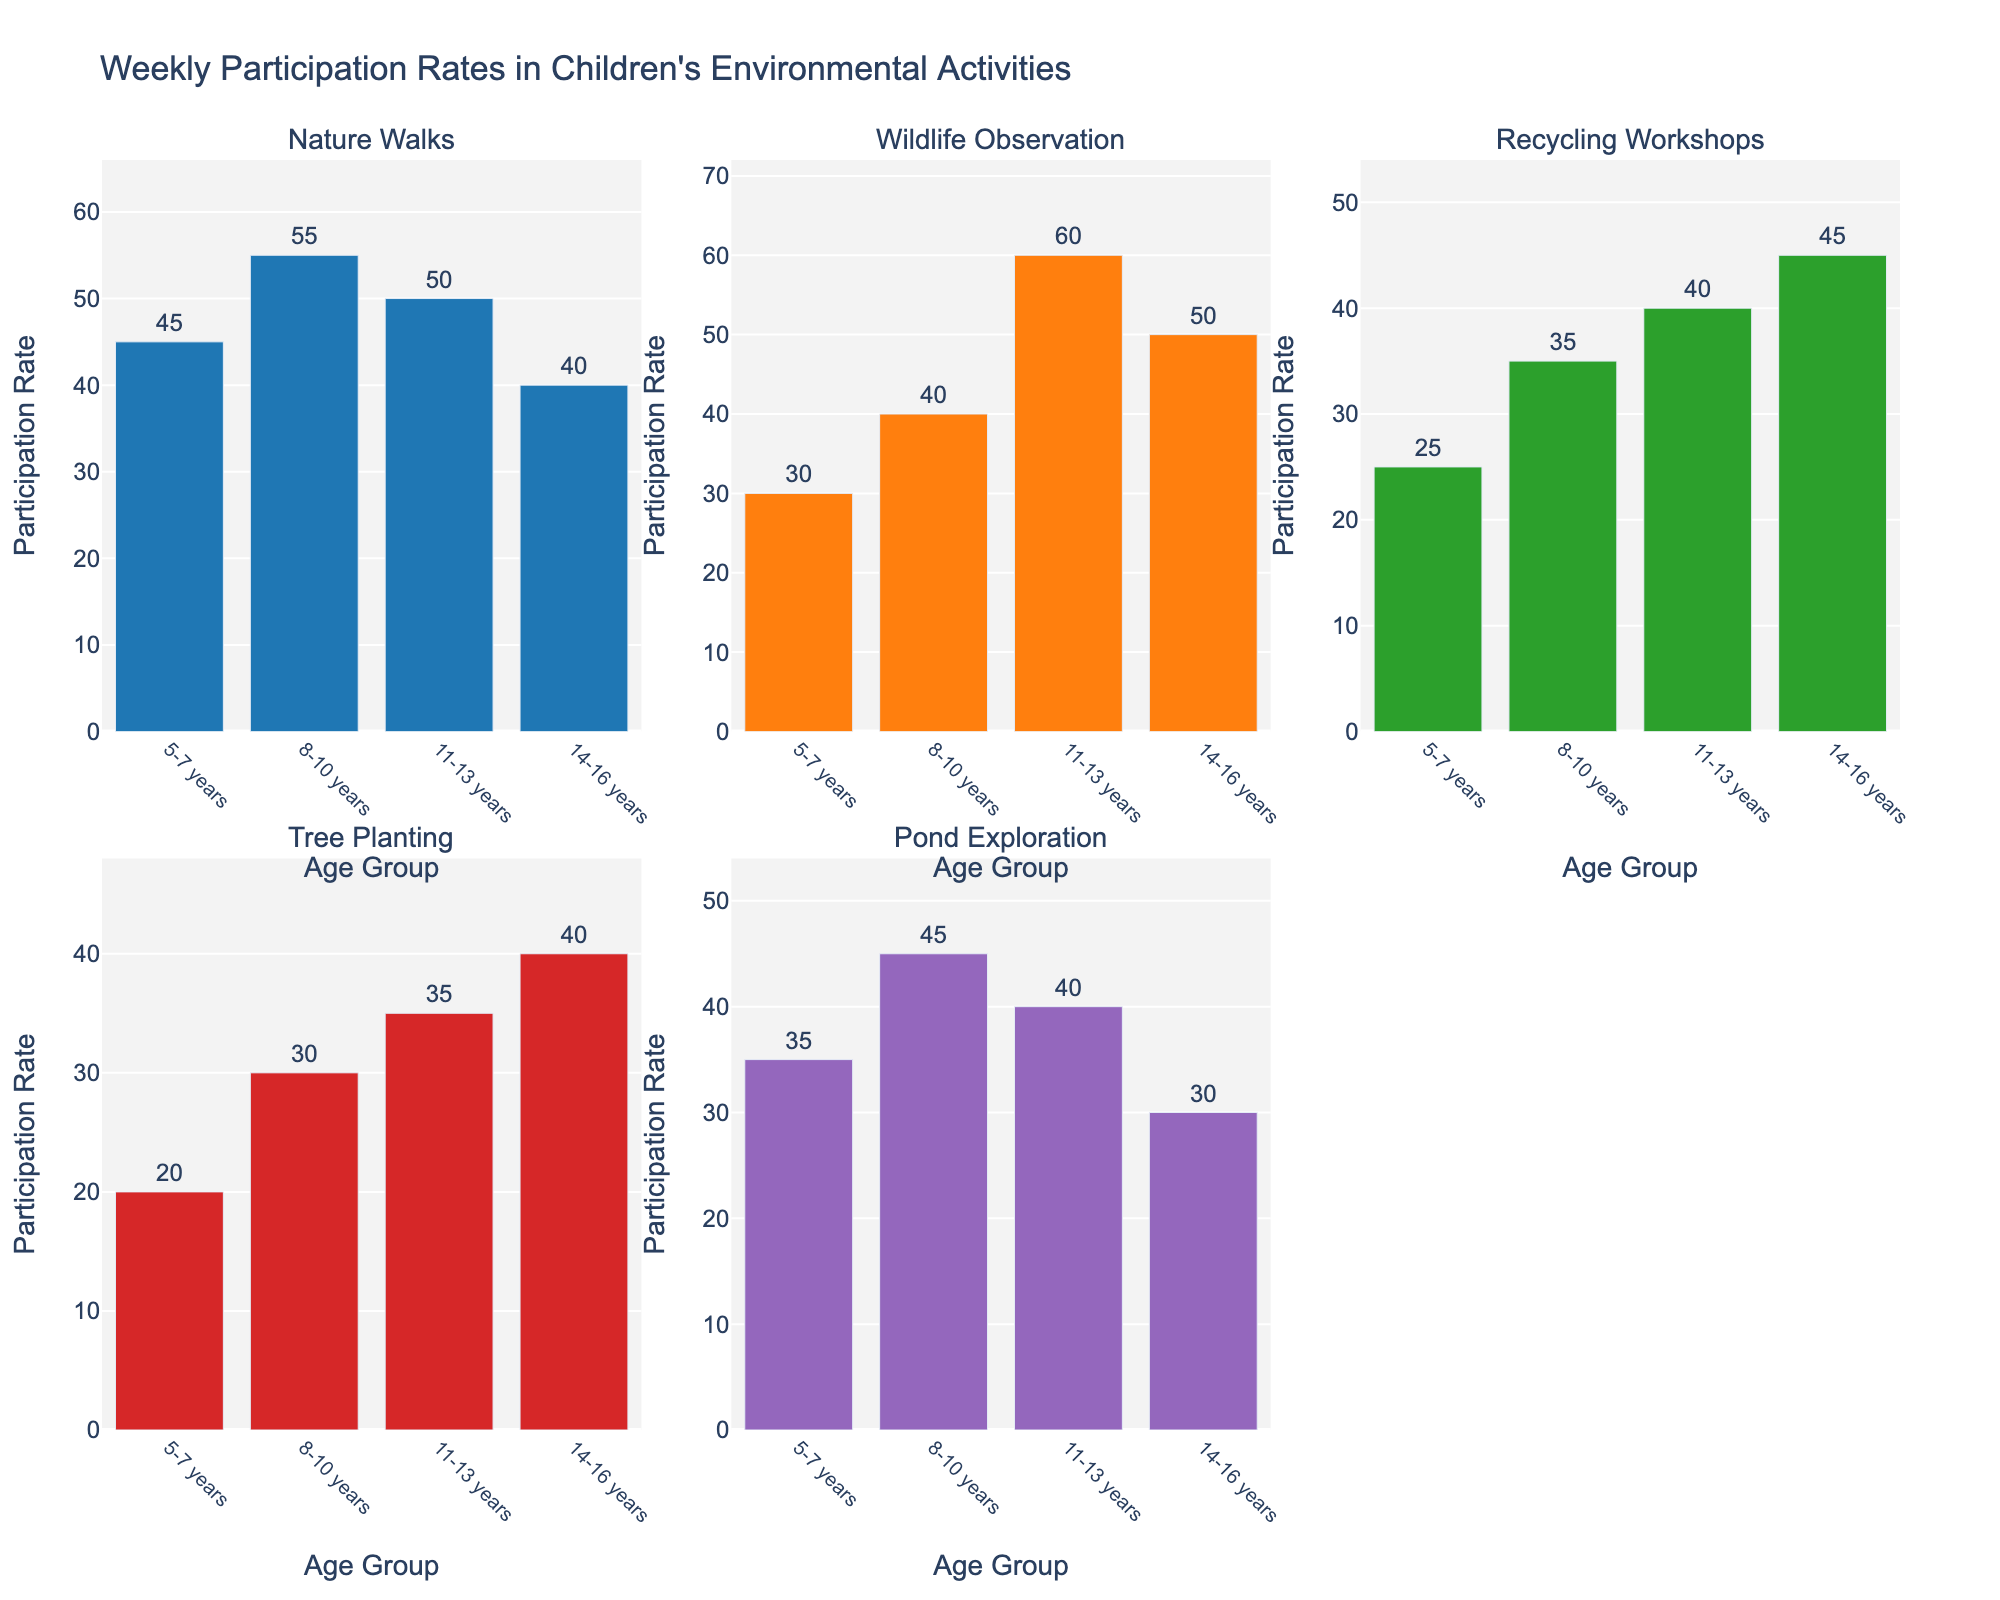What is the participation rate for Nature Walks in the 8-10 years age group? Look at the subplot for Nature Walks and find the bar that represents the 8-10 years age group. The label above the bar shows the participation rate.
Answer: 55 Which activity has the highest participation rate for the 11-13 years age group? Find the subplot for each activity and note the participation rate for the 11-13 years age group. Compare these rates to see which one is highest.
Answer: Wildlife Observation How does the participation rate in Tree Planting for the 5-7 years age group compare to that for the 14-16 years age group? Locate the subplots for Tree Planting. Compare the heights of the bars for the 5-7 years group and the 14-16 years group.
Answer: 20 for 5-7 years, 40 for 14-16 years What is the average participation rate for Recycling Workshops across all age groups? Find the Recycling Workshops subplot. Add the participation rates for all age groups and divide by the number of age groups (4). [(25 + 35 + 40 + 45) / 4 = 36.25]
Answer: 36.25 Which age group has the lowest participation rate in Pond Exploration? Look at the subplot for Pond Exploration. Compare the heights of the bars to determine which age group has the lowest rate.
Answer: 14-16 years What is the total participation rate for the 8-10 years age group across all activities? Add the participation rates for all activities for the 8-10 years age group. [55 + 40 + 35 + 30 + 45 = 205]
Answer: 205 Is the participation rate for Nature Walks higher for the 11-13 years age group than for the 14-16 years age group? Compare the heights of the bars for the 11-13 years and 14-16 years groups in the Nature Walks subplot.
Answer: Yes What is the difference between the highest and lowest participation rates for the 5-7 years age group? Identify the highest and lowest participation rates for the 5-7 years age group across all subplots. Subtract the lowest rate from the highest rate. [45 - 20 = 25]
Answer: 25 Which activity shows a decreasing trend in participation rates as age increases? Look at the subplots and observe the trend in participation rates across age groups. Identify the activity where the rate decreases with age.
Answer: Pond Exploration 